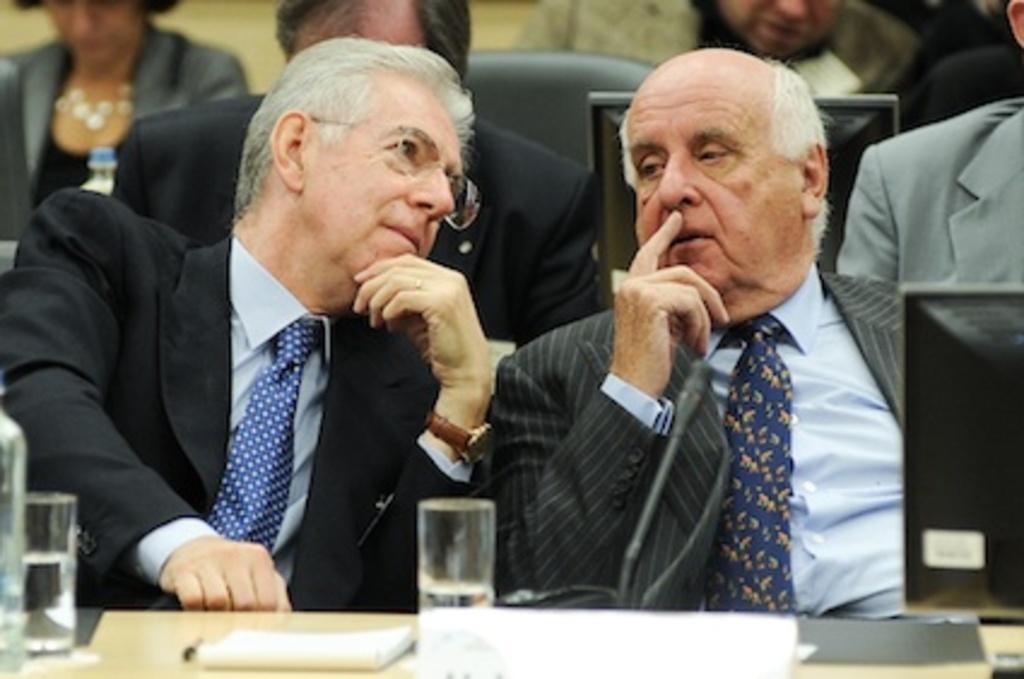How would you summarize this image in a sentence or two? In the image I can see two people wearing suits and sitting in front of the table on which there are two glasses, screen, papers and behind there are some other people. 